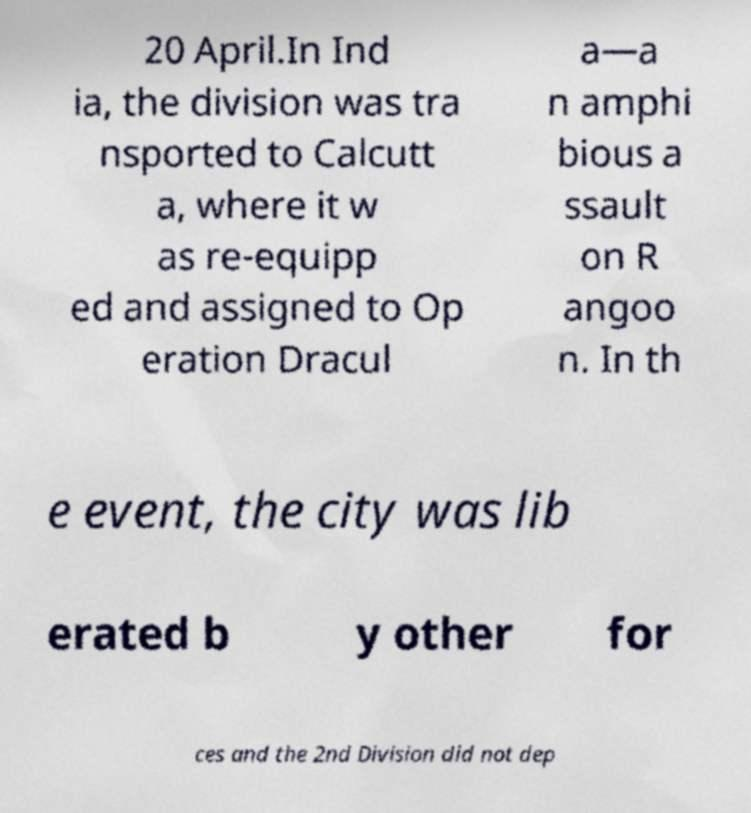For documentation purposes, I need the text within this image transcribed. Could you provide that? 20 April.In Ind ia, the division was tra nsported to Calcutt a, where it w as re-equipp ed and assigned to Op eration Dracul a—a n amphi bious a ssault on R angoo n. In th e event, the city was lib erated b y other for ces and the 2nd Division did not dep 